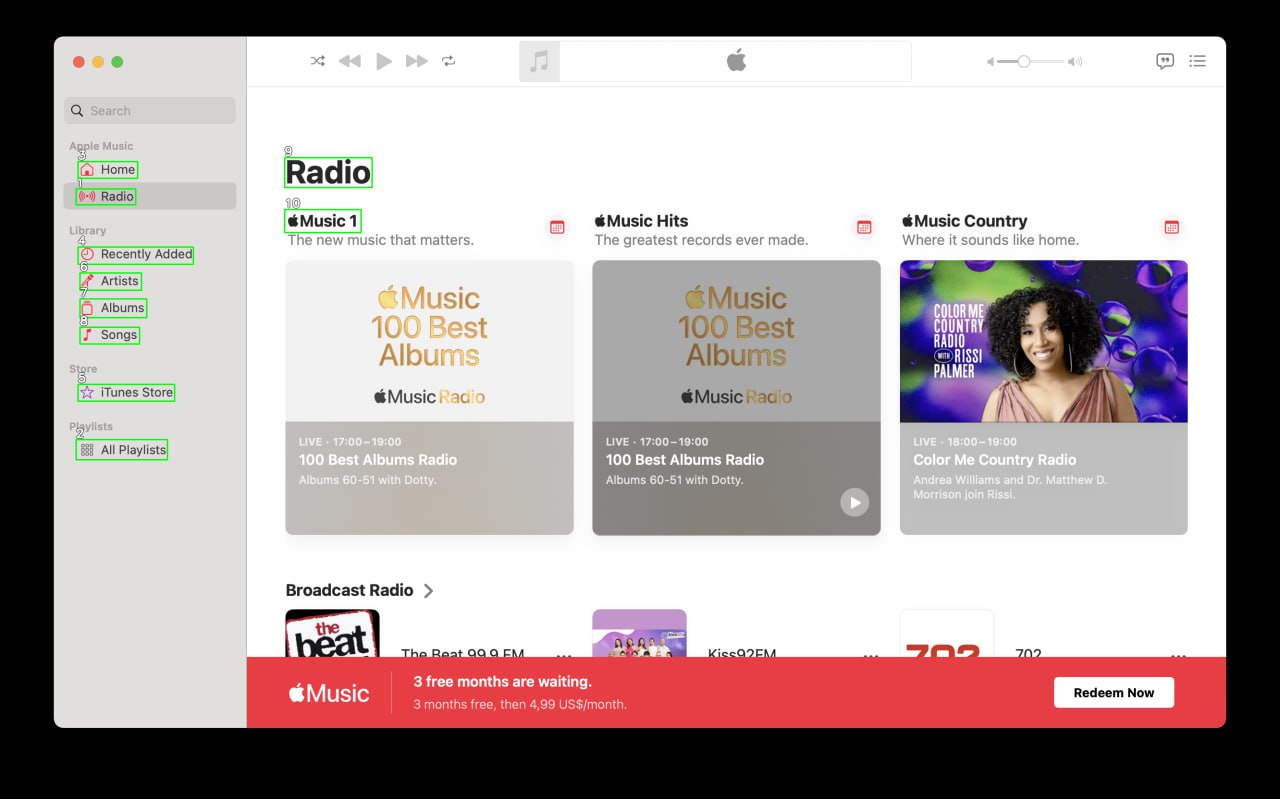Your task is to analyze the screenshot of the {app_name} on MacOS.  The screenshot is segmented with bounding boxes, each labeled with a number. The labels are always white numbers with a black outline. Number is always situated in the top left corner above the box. Describe each of the boxes numbered 1 to 10. For each identified element, provide a description that correlates with its functionality. If the element type is AXImage, write an alternative text describing the image content. Include text from the box if it is presented. Provide the output in the JSON format. Here is the JSON output analyzing the numbered elements in the Apple Music app screenshot:

{
  "1": {
    "type": "Image",
    "altText": "Apple Music logo",
    "description": "The Apple Music logo, indicating this is the Radio section of the Apple Music app."
  },
  "2": {
    "type": "Image",
    "altText": "Music Hits radio station album art",
    "description": "Album art for Apple Music's Music Hits radio station, showing some of the greatest hit records ever made."
  },
  "3": {
    "type": "Image", 
    "altText": "Music Country radio station album art",
    "description": "Album art for Apple Music's Country radio station, focusing on country music hits."
  },
  "4": {
    "type": "Image",
    "altText": "Color Me Country radio show hosted by Andrea Williams",
    "description": "Promotional image for the Color Me Country radio show on Apple Music Country radio, hosted by Andrea Williams and a guest. The image depicts a smiling African-American woman with curly hair."
  },
  "5": {
    "type": "Heading",
    "text": "Broadcast Radio",
    "description": "Text heading indicating a section for streaming live broadcast radio stations."
  },
  "6": {
    "type": "Image",
    "altText": "The Beat 99.9 FM radio station logo",
    "description": "Logo for The Beat 99.9 FM radio station."
  },
  "7": {
    "type": "Heading",
    "text": "3 free months are waiting. 3 months free, then $4.99 US$/month.",
    "description": "Promotional text offering a 3 month free trial of Apple Music, then $4.99/month after the trial period."
  },
  "8": {
    "type": "Button",
    "label": "Redeem Now",
    "description": "Button to redeem the 3 month free trial offer and start an Apple Music subscription."
  }
} 